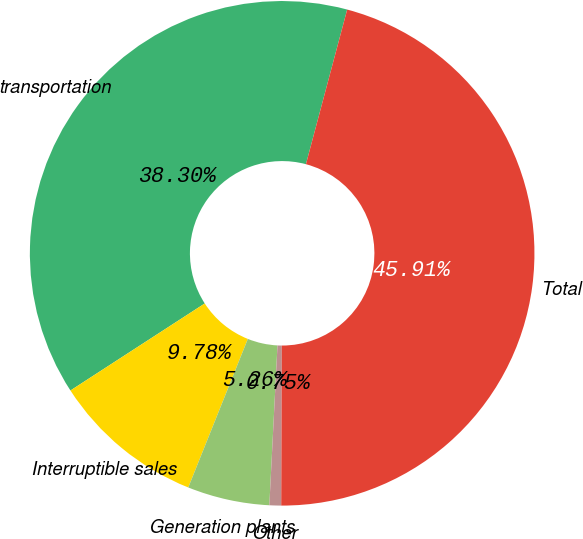<chart> <loc_0><loc_0><loc_500><loc_500><pie_chart><fcel>transportation<fcel>Interruptible sales<fcel>Generation plants<fcel>Other<fcel>Total<nl><fcel>38.3%<fcel>9.78%<fcel>5.26%<fcel>0.75%<fcel>45.91%<nl></chart> 